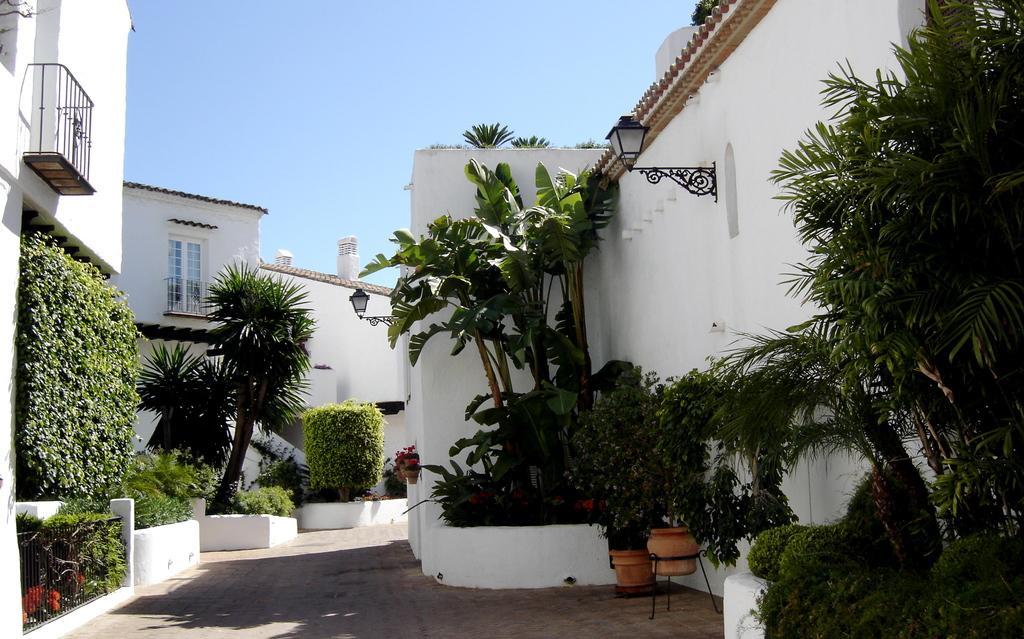How would you summarize this image in a sentence or two? In this picture we can see house plants, trees, buildings with windows, lamps and in the background we can see the sky. 